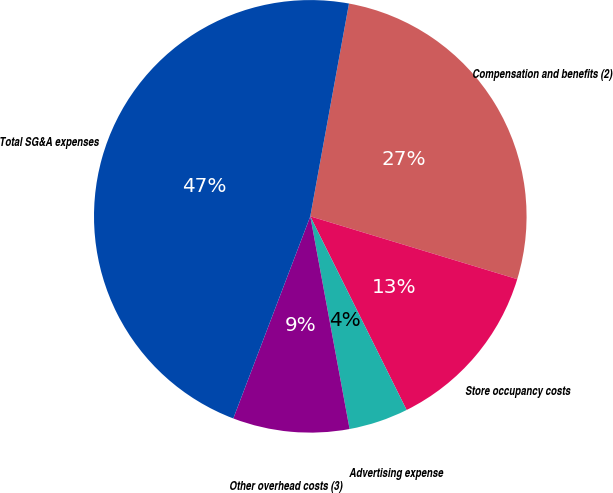Convert chart to OTSL. <chart><loc_0><loc_0><loc_500><loc_500><pie_chart><fcel>Compensation and benefits (2)<fcel>Store occupancy costs<fcel>Advertising expense<fcel>Other overhead costs (3)<fcel>Total SG&A expenses<nl><fcel>26.83%<fcel>12.96%<fcel>4.44%<fcel>8.7%<fcel>47.07%<nl></chart> 